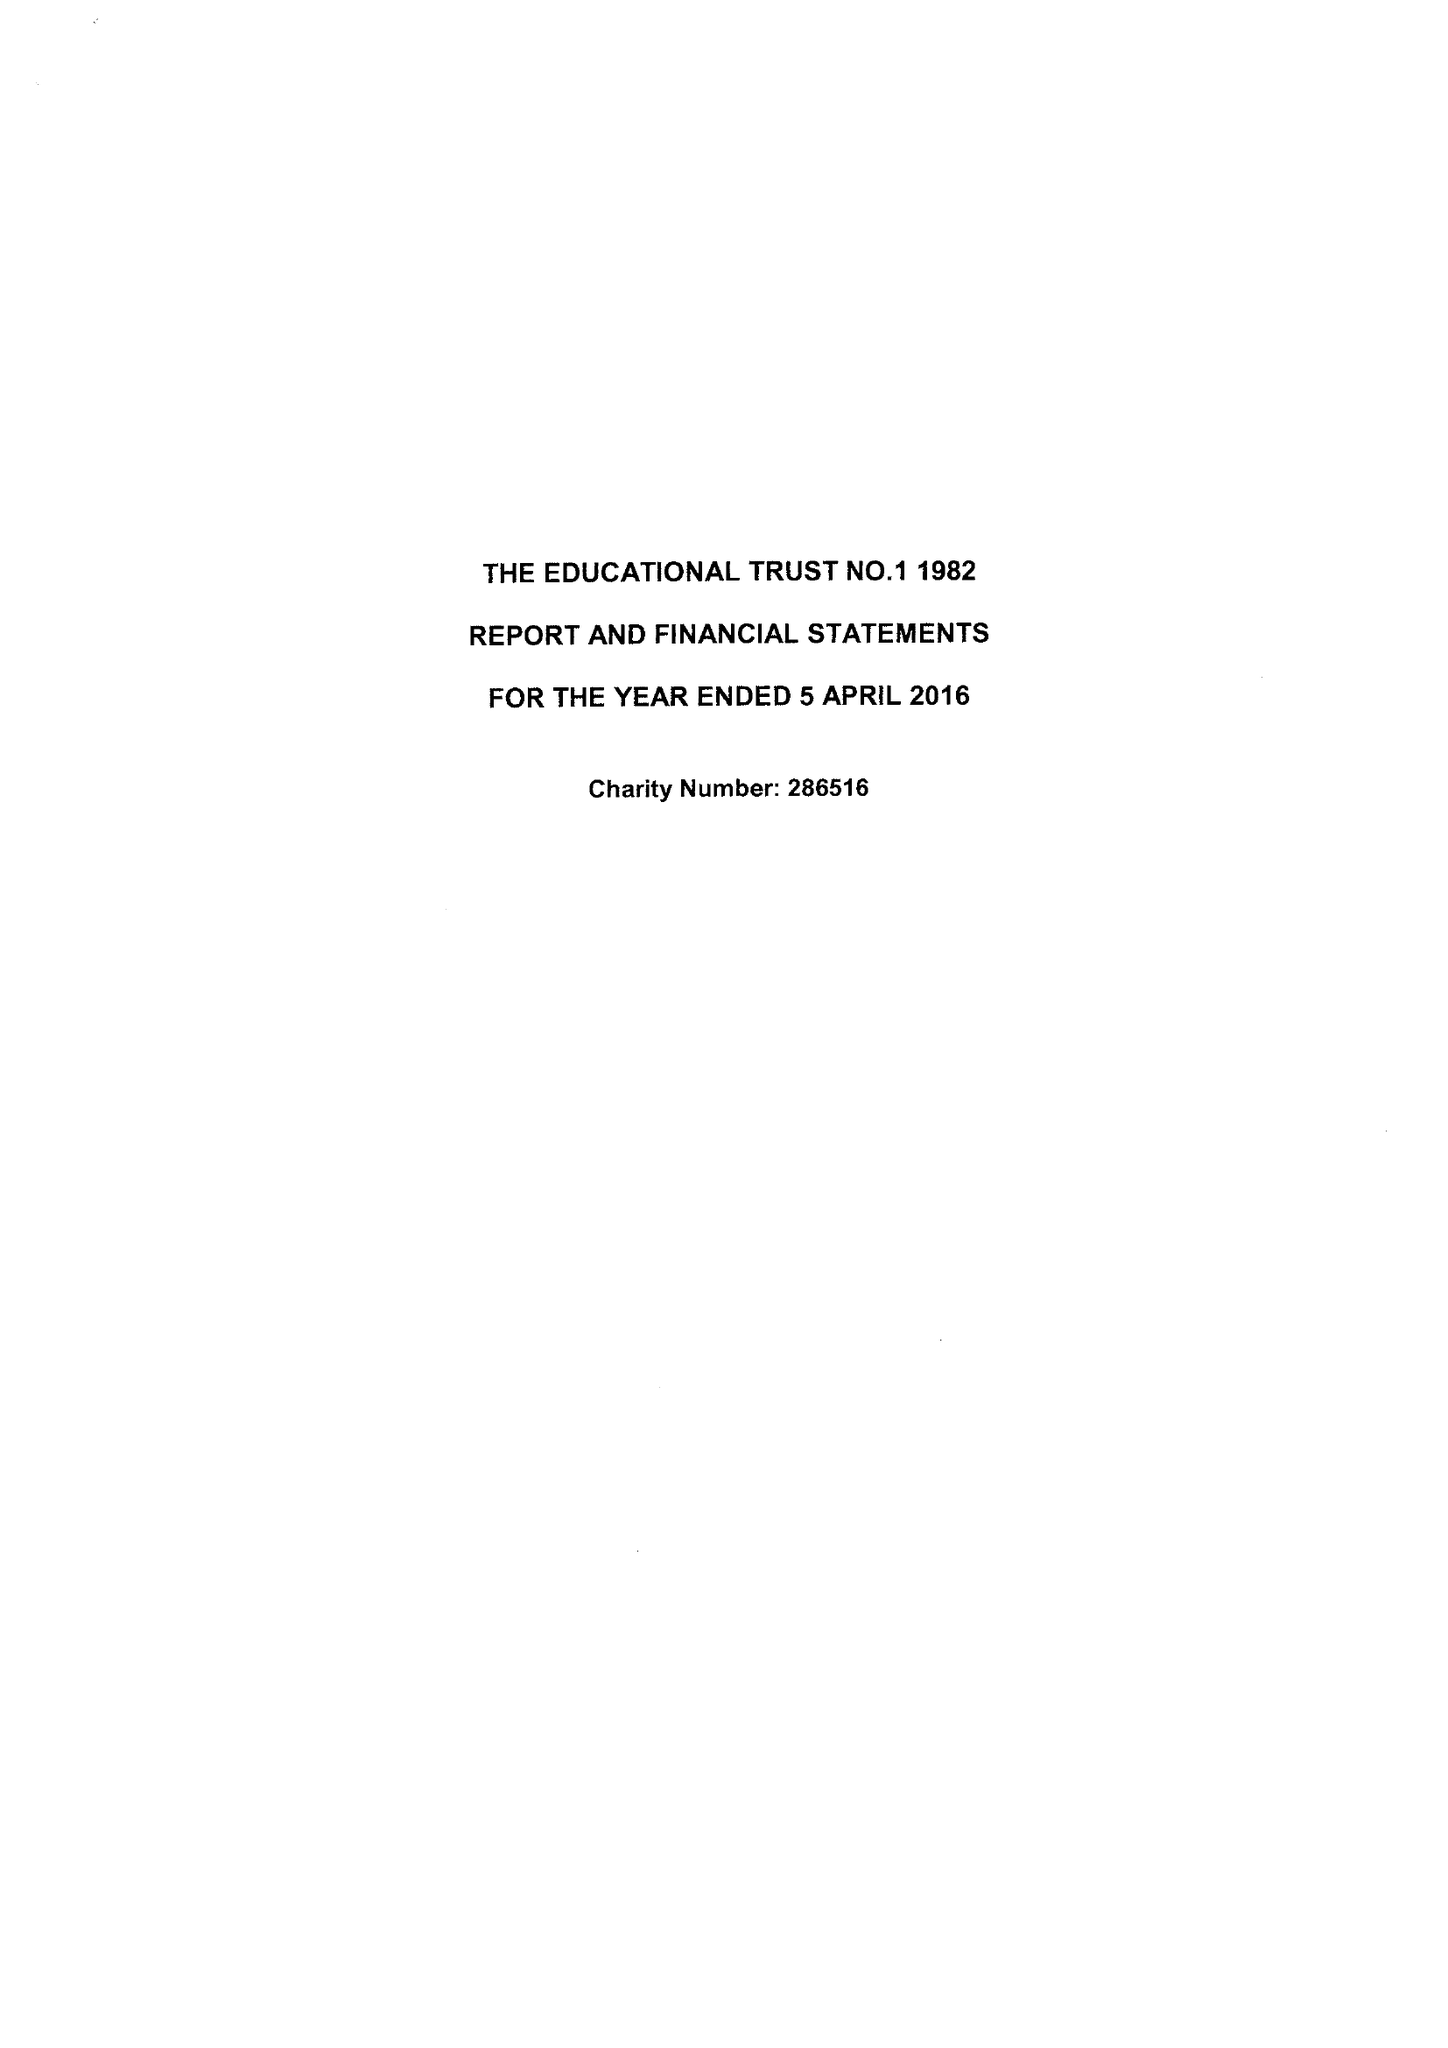What is the value for the charity_number?
Answer the question using a single word or phrase. 286516 